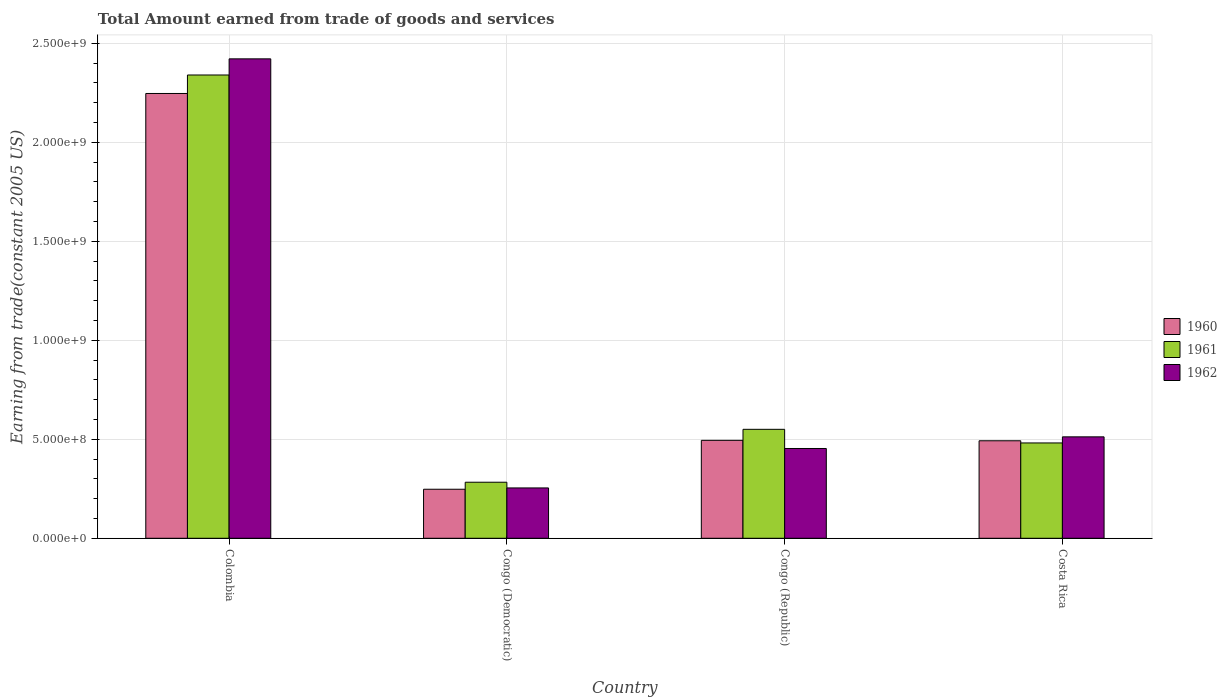Are the number of bars per tick equal to the number of legend labels?
Your answer should be very brief. Yes. Are the number of bars on each tick of the X-axis equal?
Your answer should be compact. Yes. How many bars are there on the 1st tick from the right?
Keep it short and to the point. 3. In how many cases, is the number of bars for a given country not equal to the number of legend labels?
Give a very brief answer. 0. What is the total amount earned by trading goods and services in 1961 in Congo (Republic)?
Ensure brevity in your answer.  5.50e+08. Across all countries, what is the maximum total amount earned by trading goods and services in 1960?
Make the answer very short. 2.25e+09. Across all countries, what is the minimum total amount earned by trading goods and services in 1962?
Offer a very short reply. 2.54e+08. In which country was the total amount earned by trading goods and services in 1960 maximum?
Provide a succinct answer. Colombia. In which country was the total amount earned by trading goods and services in 1960 minimum?
Ensure brevity in your answer.  Congo (Democratic). What is the total total amount earned by trading goods and services in 1960 in the graph?
Your answer should be compact. 3.48e+09. What is the difference between the total amount earned by trading goods and services in 1960 in Colombia and that in Congo (Democratic)?
Make the answer very short. 2.00e+09. What is the difference between the total amount earned by trading goods and services in 1960 in Costa Rica and the total amount earned by trading goods and services in 1962 in Congo (Republic)?
Provide a short and direct response. 3.89e+07. What is the average total amount earned by trading goods and services in 1961 per country?
Make the answer very short. 9.14e+08. What is the difference between the total amount earned by trading goods and services of/in 1960 and total amount earned by trading goods and services of/in 1962 in Colombia?
Your answer should be very brief. -1.75e+08. What is the ratio of the total amount earned by trading goods and services in 1962 in Colombia to that in Congo (Democratic)?
Offer a terse response. 9.52. Is the total amount earned by trading goods and services in 1960 in Colombia less than that in Costa Rica?
Give a very brief answer. No. What is the difference between the highest and the second highest total amount earned by trading goods and services in 1960?
Provide a succinct answer. 1.75e+09. What is the difference between the highest and the lowest total amount earned by trading goods and services in 1961?
Give a very brief answer. 2.06e+09. In how many countries, is the total amount earned by trading goods and services in 1961 greater than the average total amount earned by trading goods and services in 1961 taken over all countries?
Provide a succinct answer. 1. What does the 3rd bar from the left in Congo (Democratic) represents?
Your answer should be very brief. 1962. Does the graph contain any zero values?
Provide a short and direct response. No. Does the graph contain grids?
Provide a succinct answer. Yes. What is the title of the graph?
Your answer should be very brief. Total Amount earned from trade of goods and services. Does "1997" appear as one of the legend labels in the graph?
Offer a very short reply. No. What is the label or title of the X-axis?
Your answer should be compact. Country. What is the label or title of the Y-axis?
Provide a succinct answer. Earning from trade(constant 2005 US). What is the Earning from trade(constant 2005 US) in 1960 in Colombia?
Your answer should be very brief. 2.25e+09. What is the Earning from trade(constant 2005 US) in 1961 in Colombia?
Ensure brevity in your answer.  2.34e+09. What is the Earning from trade(constant 2005 US) in 1962 in Colombia?
Provide a succinct answer. 2.42e+09. What is the Earning from trade(constant 2005 US) in 1960 in Congo (Democratic)?
Your answer should be compact. 2.48e+08. What is the Earning from trade(constant 2005 US) in 1961 in Congo (Democratic)?
Your answer should be compact. 2.83e+08. What is the Earning from trade(constant 2005 US) of 1962 in Congo (Democratic)?
Make the answer very short. 2.54e+08. What is the Earning from trade(constant 2005 US) in 1960 in Congo (Republic)?
Your response must be concise. 4.95e+08. What is the Earning from trade(constant 2005 US) of 1961 in Congo (Republic)?
Ensure brevity in your answer.  5.50e+08. What is the Earning from trade(constant 2005 US) of 1962 in Congo (Republic)?
Ensure brevity in your answer.  4.53e+08. What is the Earning from trade(constant 2005 US) in 1960 in Costa Rica?
Provide a succinct answer. 4.92e+08. What is the Earning from trade(constant 2005 US) in 1961 in Costa Rica?
Provide a short and direct response. 4.81e+08. What is the Earning from trade(constant 2005 US) of 1962 in Costa Rica?
Your response must be concise. 5.12e+08. Across all countries, what is the maximum Earning from trade(constant 2005 US) of 1960?
Your response must be concise. 2.25e+09. Across all countries, what is the maximum Earning from trade(constant 2005 US) in 1961?
Give a very brief answer. 2.34e+09. Across all countries, what is the maximum Earning from trade(constant 2005 US) of 1962?
Keep it short and to the point. 2.42e+09. Across all countries, what is the minimum Earning from trade(constant 2005 US) of 1960?
Offer a terse response. 2.48e+08. Across all countries, what is the minimum Earning from trade(constant 2005 US) in 1961?
Your response must be concise. 2.83e+08. Across all countries, what is the minimum Earning from trade(constant 2005 US) of 1962?
Offer a terse response. 2.54e+08. What is the total Earning from trade(constant 2005 US) of 1960 in the graph?
Offer a very short reply. 3.48e+09. What is the total Earning from trade(constant 2005 US) in 1961 in the graph?
Provide a succinct answer. 3.65e+09. What is the total Earning from trade(constant 2005 US) in 1962 in the graph?
Provide a succinct answer. 3.64e+09. What is the difference between the Earning from trade(constant 2005 US) of 1960 in Colombia and that in Congo (Democratic)?
Your response must be concise. 2.00e+09. What is the difference between the Earning from trade(constant 2005 US) of 1961 in Colombia and that in Congo (Democratic)?
Ensure brevity in your answer.  2.06e+09. What is the difference between the Earning from trade(constant 2005 US) in 1962 in Colombia and that in Congo (Democratic)?
Make the answer very short. 2.17e+09. What is the difference between the Earning from trade(constant 2005 US) in 1960 in Colombia and that in Congo (Republic)?
Your answer should be very brief. 1.75e+09. What is the difference between the Earning from trade(constant 2005 US) of 1961 in Colombia and that in Congo (Republic)?
Offer a very short reply. 1.79e+09. What is the difference between the Earning from trade(constant 2005 US) in 1962 in Colombia and that in Congo (Republic)?
Provide a short and direct response. 1.97e+09. What is the difference between the Earning from trade(constant 2005 US) in 1960 in Colombia and that in Costa Rica?
Provide a short and direct response. 1.75e+09. What is the difference between the Earning from trade(constant 2005 US) of 1961 in Colombia and that in Costa Rica?
Provide a short and direct response. 1.86e+09. What is the difference between the Earning from trade(constant 2005 US) in 1962 in Colombia and that in Costa Rica?
Provide a short and direct response. 1.91e+09. What is the difference between the Earning from trade(constant 2005 US) in 1960 in Congo (Democratic) and that in Congo (Republic)?
Ensure brevity in your answer.  -2.47e+08. What is the difference between the Earning from trade(constant 2005 US) of 1961 in Congo (Democratic) and that in Congo (Republic)?
Provide a short and direct response. -2.67e+08. What is the difference between the Earning from trade(constant 2005 US) in 1962 in Congo (Democratic) and that in Congo (Republic)?
Offer a terse response. -1.99e+08. What is the difference between the Earning from trade(constant 2005 US) in 1960 in Congo (Democratic) and that in Costa Rica?
Your response must be concise. -2.45e+08. What is the difference between the Earning from trade(constant 2005 US) of 1961 in Congo (Democratic) and that in Costa Rica?
Your answer should be very brief. -1.98e+08. What is the difference between the Earning from trade(constant 2005 US) of 1962 in Congo (Democratic) and that in Costa Rica?
Offer a terse response. -2.58e+08. What is the difference between the Earning from trade(constant 2005 US) in 1960 in Congo (Republic) and that in Costa Rica?
Provide a succinct answer. 2.28e+06. What is the difference between the Earning from trade(constant 2005 US) of 1961 in Congo (Republic) and that in Costa Rica?
Offer a very short reply. 6.87e+07. What is the difference between the Earning from trade(constant 2005 US) in 1962 in Congo (Republic) and that in Costa Rica?
Offer a very short reply. -5.88e+07. What is the difference between the Earning from trade(constant 2005 US) of 1960 in Colombia and the Earning from trade(constant 2005 US) of 1961 in Congo (Democratic)?
Offer a very short reply. 1.96e+09. What is the difference between the Earning from trade(constant 2005 US) in 1960 in Colombia and the Earning from trade(constant 2005 US) in 1962 in Congo (Democratic)?
Offer a terse response. 1.99e+09. What is the difference between the Earning from trade(constant 2005 US) of 1961 in Colombia and the Earning from trade(constant 2005 US) of 1962 in Congo (Democratic)?
Provide a succinct answer. 2.09e+09. What is the difference between the Earning from trade(constant 2005 US) of 1960 in Colombia and the Earning from trade(constant 2005 US) of 1961 in Congo (Republic)?
Your response must be concise. 1.70e+09. What is the difference between the Earning from trade(constant 2005 US) of 1960 in Colombia and the Earning from trade(constant 2005 US) of 1962 in Congo (Republic)?
Your answer should be very brief. 1.79e+09. What is the difference between the Earning from trade(constant 2005 US) of 1961 in Colombia and the Earning from trade(constant 2005 US) of 1962 in Congo (Republic)?
Give a very brief answer. 1.89e+09. What is the difference between the Earning from trade(constant 2005 US) of 1960 in Colombia and the Earning from trade(constant 2005 US) of 1961 in Costa Rica?
Give a very brief answer. 1.76e+09. What is the difference between the Earning from trade(constant 2005 US) of 1960 in Colombia and the Earning from trade(constant 2005 US) of 1962 in Costa Rica?
Give a very brief answer. 1.73e+09. What is the difference between the Earning from trade(constant 2005 US) of 1961 in Colombia and the Earning from trade(constant 2005 US) of 1962 in Costa Rica?
Offer a very short reply. 1.83e+09. What is the difference between the Earning from trade(constant 2005 US) in 1960 in Congo (Democratic) and the Earning from trade(constant 2005 US) in 1961 in Congo (Republic)?
Ensure brevity in your answer.  -3.03e+08. What is the difference between the Earning from trade(constant 2005 US) of 1960 in Congo (Democratic) and the Earning from trade(constant 2005 US) of 1962 in Congo (Republic)?
Offer a terse response. -2.06e+08. What is the difference between the Earning from trade(constant 2005 US) in 1961 in Congo (Democratic) and the Earning from trade(constant 2005 US) in 1962 in Congo (Republic)?
Your answer should be compact. -1.70e+08. What is the difference between the Earning from trade(constant 2005 US) of 1960 in Congo (Democratic) and the Earning from trade(constant 2005 US) of 1961 in Costa Rica?
Offer a very short reply. -2.34e+08. What is the difference between the Earning from trade(constant 2005 US) of 1960 in Congo (Democratic) and the Earning from trade(constant 2005 US) of 1962 in Costa Rica?
Your answer should be very brief. -2.65e+08. What is the difference between the Earning from trade(constant 2005 US) in 1961 in Congo (Democratic) and the Earning from trade(constant 2005 US) in 1962 in Costa Rica?
Offer a very short reply. -2.29e+08. What is the difference between the Earning from trade(constant 2005 US) of 1960 in Congo (Republic) and the Earning from trade(constant 2005 US) of 1961 in Costa Rica?
Your response must be concise. 1.32e+07. What is the difference between the Earning from trade(constant 2005 US) of 1960 in Congo (Republic) and the Earning from trade(constant 2005 US) of 1962 in Costa Rica?
Ensure brevity in your answer.  -1.76e+07. What is the difference between the Earning from trade(constant 2005 US) in 1961 in Congo (Republic) and the Earning from trade(constant 2005 US) in 1962 in Costa Rica?
Offer a terse response. 3.80e+07. What is the average Earning from trade(constant 2005 US) in 1960 per country?
Give a very brief answer. 8.70e+08. What is the average Earning from trade(constant 2005 US) of 1961 per country?
Make the answer very short. 9.14e+08. What is the average Earning from trade(constant 2005 US) in 1962 per country?
Provide a succinct answer. 9.10e+08. What is the difference between the Earning from trade(constant 2005 US) in 1960 and Earning from trade(constant 2005 US) in 1961 in Colombia?
Ensure brevity in your answer.  -9.33e+07. What is the difference between the Earning from trade(constant 2005 US) of 1960 and Earning from trade(constant 2005 US) of 1962 in Colombia?
Give a very brief answer. -1.75e+08. What is the difference between the Earning from trade(constant 2005 US) in 1961 and Earning from trade(constant 2005 US) in 1962 in Colombia?
Keep it short and to the point. -8.16e+07. What is the difference between the Earning from trade(constant 2005 US) in 1960 and Earning from trade(constant 2005 US) in 1961 in Congo (Democratic)?
Give a very brief answer. -3.54e+07. What is the difference between the Earning from trade(constant 2005 US) of 1960 and Earning from trade(constant 2005 US) of 1962 in Congo (Democratic)?
Ensure brevity in your answer.  -6.61e+06. What is the difference between the Earning from trade(constant 2005 US) in 1961 and Earning from trade(constant 2005 US) in 1962 in Congo (Democratic)?
Ensure brevity in your answer.  2.88e+07. What is the difference between the Earning from trade(constant 2005 US) in 1960 and Earning from trade(constant 2005 US) in 1961 in Congo (Republic)?
Ensure brevity in your answer.  -5.56e+07. What is the difference between the Earning from trade(constant 2005 US) of 1960 and Earning from trade(constant 2005 US) of 1962 in Congo (Republic)?
Your answer should be compact. 4.12e+07. What is the difference between the Earning from trade(constant 2005 US) in 1961 and Earning from trade(constant 2005 US) in 1962 in Congo (Republic)?
Provide a succinct answer. 9.68e+07. What is the difference between the Earning from trade(constant 2005 US) of 1960 and Earning from trade(constant 2005 US) of 1961 in Costa Rica?
Offer a very short reply. 1.09e+07. What is the difference between the Earning from trade(constant 2005 US) of 1960 and Earning from trade(constant 2005 US) of 1962 in Costa Rica?
Your answer should be very brief. -1.99e+07. What is the difference between the Earning from trade(constant 2005 US) in 1961 and Earning from trade(constant 2005 US) in 1962 in Costa Rica?
Ensure brevity in your answer.  -3.08e+07. What is the ratio of the Earning from trade(constant 2005 US) of 1960 in Colombia to that in Congo (Democratic)?
Provide a succinct answer. 9.07. What is the ratio of the Earning from trade(constant 2005 US) of 1961 in Colombia to that in Congo (Democratic)?
Provide a short and direct response. 8.26. What is the ratio of the Earning from trade(constant 2005 US) in 1962 in Colombia to that in Congo (Democratic)?
Provide a succinct answer. 9.52. What is the ratio of the Earning from trade(constant 2005 US) of 1960 in Colombia to that in Congo (Republic)?
Your answer should be very brief. 4.54. What is the ratio of the Earning from trade(constant 2005 US) in 1961 in Colombia to that in Congo (Republic)?
Keep it short and to the point. 4.25. What is the ratio of the Earning from trade(constant 2005 US) in 1962 in Colombia to that in Congo (Republic)?
Your answer should be compact. 5.34. What is the ratio of the Earning from trade(constant 2005 US) in 1960 in Colombia to that in Costa Rica?
Offer a terse response. 4.56. What is the ratio of the Earning from trade(constant 2005 US) in 1961 in Colombia to that in Costa Rica?
Make the answer very short. 4.86. What is the ratio of the Earning from trade(constant 2005 US) in 1962 in Colombia to that in Costa Rica?
Keep it short and to the point. 4.73. What is the ratio of the Earning from trade(constant 2005 US) of 1960 in Congo (Democratic) to that in Congo (Republic)?
Provide a short and direct response. 0.5. What is the ratio of the Earning from trade(constant 2005 US) of 1961 in Congo (Democratic) to that in Congo (Republic)?
Offer a terse response. 0.51. What is the ratio of the Earning from trade(constant 2005 US) in 1962 in Congo (Democratic) to that in Congo (Republic)?
Make the answer very short. 0.56. What is the ratio of the Earning from trade(constant 2005 US) in 1960 in Congo (Democratic) to that in Costa Rica?
Your answer should be very brief. 0.5. What is the ratio of the Earning from trade(constant 2005 US) of 1961 in Congo (Democratic) to that in Costa Rica?
Offer a terse response. 0.59. What is the ratio of the Earning from trade(constant 2005 US) of 1962 in Congo (Democratic) to that in Costa Rica?
Your response must be concise. 0.5. What is the ratio of the Earning from trade(constant 2005 US) in 1961 in Congo (Republic) to that in Costa Rica?
Your answer should be very brief. 1.14. What is the ratio of the Earning from trade(constant 2005 US) of 1962 in Congo (Republic) to that in Costa Rica?
Provide a short and direct response. 0.89. What is the difference between the highest and the second highest Earning from trade(constant 2005 US) of 1960?
Your answer should be compact. 1.75e+09. What is the difference between the highest and the second highest Earning from trade(constant 2005 US) of 1961?
Provide a short and direct response. 1.79e+09. What is the difference between the highest and the second highest Earning from trade(constant 2005 US) in 1962?
Keep it short and to the point. 1.91e+09. What is the difference between the highest and the lowest Earning from trade(constant 2005 US) in 1960?
Your response must be concise. 2.00e+09. What is the difference between the highest and the lowest Earning from trade(constant 2005 US) in 1961?
Offer a very short reply. 2.06e+09. What is the difference between the highest and the lowest Earning from trade(constant 2005 US) of 1962?
Offer a very short reply. 2.17e+09. 